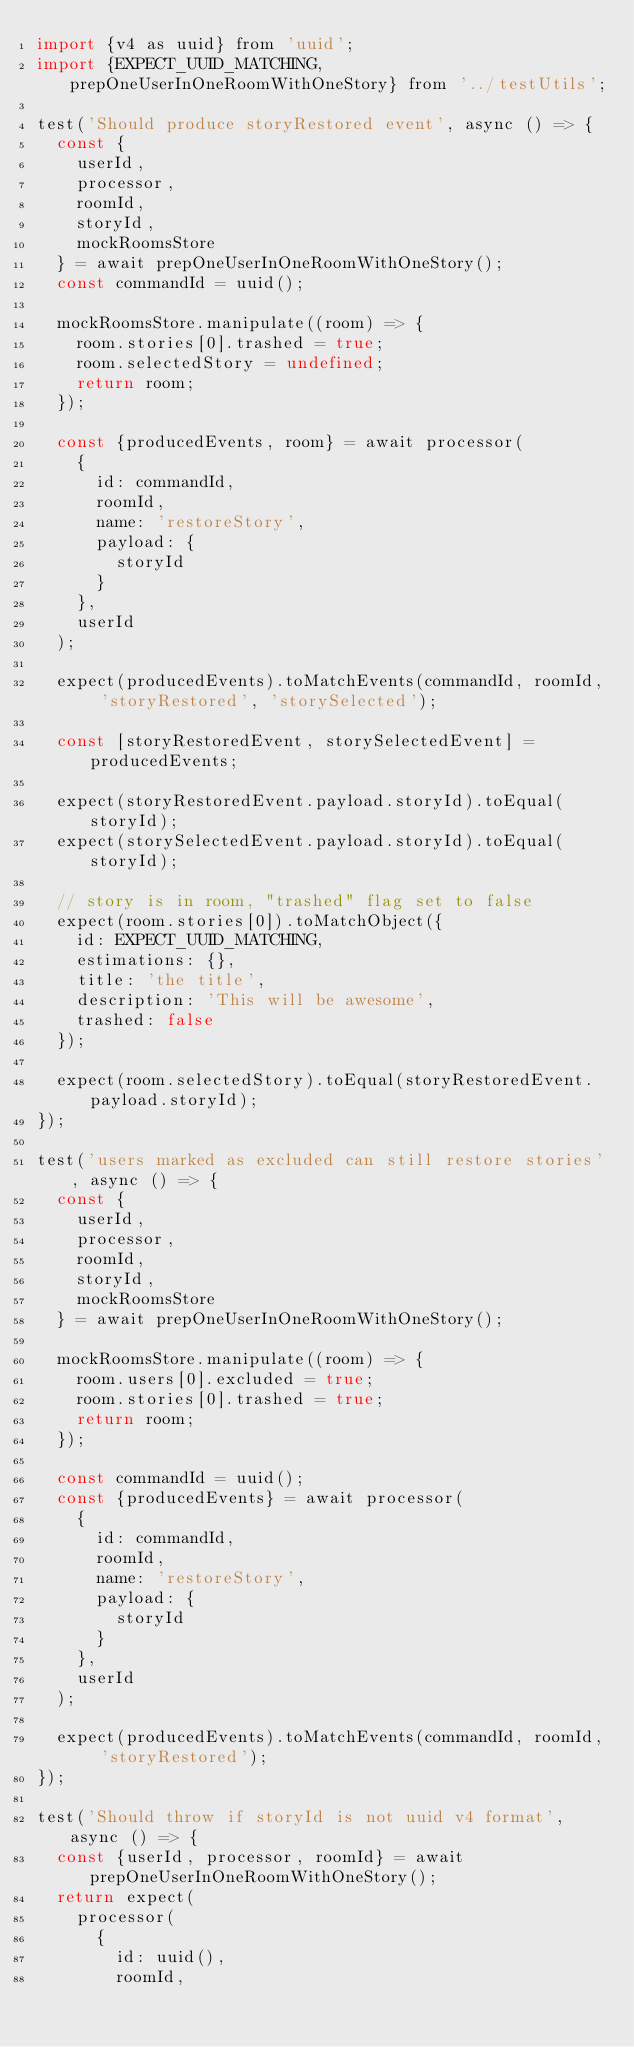<code> <loc_0><loc_0><loc_500><loc_500><_JavaScript_>import {v4 as uuid} from 'uuid';
import {EXPECT_UUID_MATCHING, prepOneUserInOneRoomWithOneStory} from '../testUtils';

test('Should produce storyRestored event', async () => {
  const {
    userId,
    processor,
    roomId,
    storyId,
    mockRoomsStore
  } = await prepOneUserInOneRoomWithOneStory();
  const commandId = uuid();

  mockRoomsStore.manipulate((room) => {
    room.stories[0].trashed = true;
    room.selectedStory = undefined;
    return room;
  });

  const {producedEvents, room} = await processor(
    {
      id: commandId,
      roomId,
      name: 'restoreStory',
      payload: {
        storyId
      }
    },
    userId
  );

  expect(producedEvents).toMatchEvents(commandId, roomId, 'storyRestored', 'storySelected');

  const [storyRestoredEvent, storySelectedEvent] = producedEvents;

  expect(storyRestoredEvent.payload.storyId).toEqual(storyId);
  expect(storySelectedEvent.payload.storyId).toEqual(storyId);

  // story is in room, "trashed" flag set to false
  expect(room.stories[0]).toMatchObject({
    id: EXPECT_UUID_MATCHING,
    estimations: {},
    title: 'the title',
    description: 'This will be awesome',
    trashed: false
  });

  expect(room.selectedStory).toEqual(storyRestoredEvent.payload.storyId);
});

test('users marked as excluded can still restore stories', async () => {
  const {
    userId,
    processor,
    roomId,
    storyId,
    mockRoomsStore
  } = await prepOneUserInOneRoomWithOneStory();

  mockRoomsStore.manipulate((room) => {
    room.users[0].excluded = true;
    room.stories[0].trashed = true;
    return room;
  });

  const commandId = uuid();
  const {producedEvents} = await processor(
    {
      id: commandId,
      roomId,
      name: 'restoreStory',
      payload: {
        storyId
      }
    },
    userId
  );

  expect(producedEvents).toMatchEvents(commandId, roomId, 'storyRestored');
});

test('Should throw if storyId is not uuid v4 format', async () => {
  const {userId, processor, roomId} = await prepOneUserInOneRoomWithOneStory();
  return expect(
    processor(
      {
        id: uuid(),
        roomId,</code> 